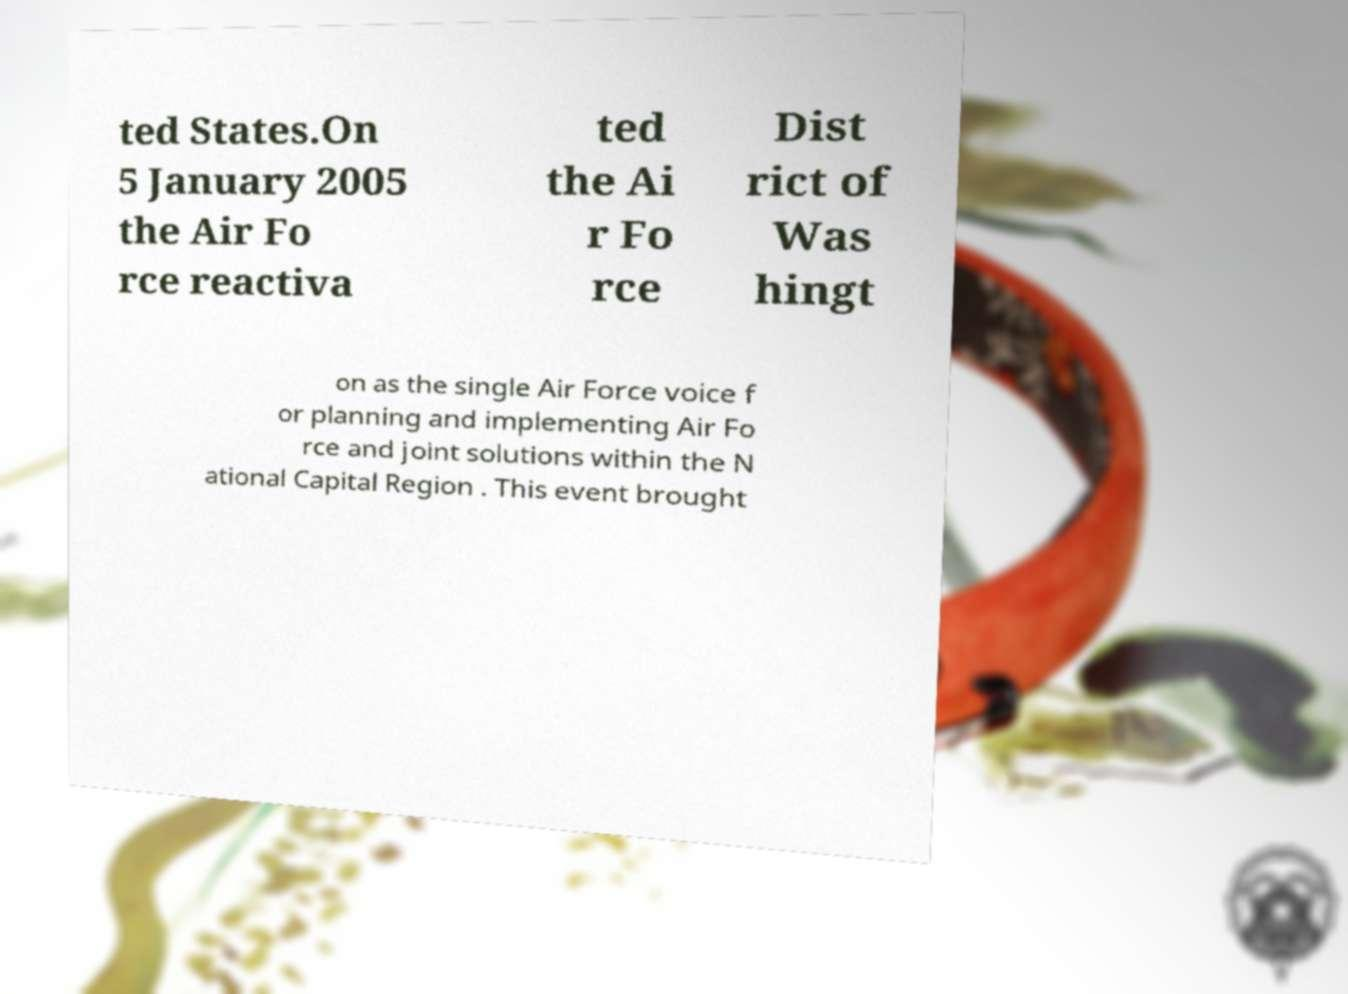Can you accurately transcribe the text from the provided image for me? ted States.On 5 January 2005 the Air Fo rce reactiva ted the Ai r Fo rce Dist rict of Was hingt on as the single Air Force voice f or planning and implementing Air Fo rce and joint solutions within the N ational Capital Region . This event brought 